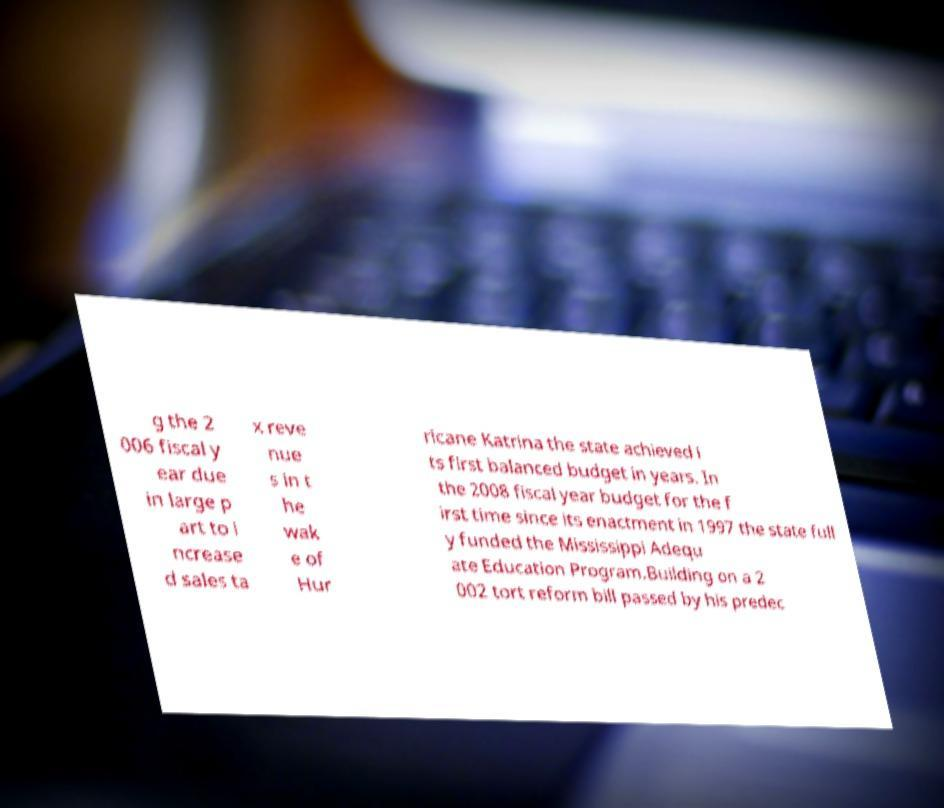I need the written content from this picture converted into text. Can you do that? g the 2 006 fiscal y ear due in large p art to i ncrease d sales ta x reve nue s in t he wak e of Hur ricane Katrina the state achieved i ts first balanced budget in years. In the 2008 fiscal year budget for the f irst time since its enactment in 1997 the state full y funded the Mississippi Adequ ate Education Program.Building on a 2 002 tort reform bill passed by his predec 